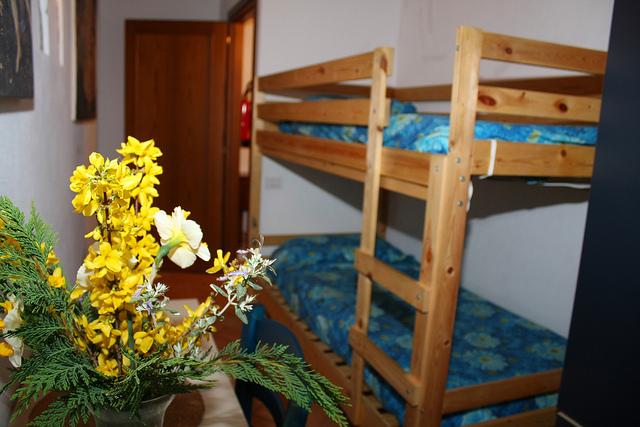What is the print of the bed linens?
Write a very short answer. Floral. Based on the flowers, what season is it?
Answer briefly. Spring. Is this the room of a married couple?
Concise answer only. No. What color are the flowers?
Keep it brief. Yellow. What is under the bed?
Write a very short answer. Another bed. How many people is this bed designed for?
Answer briefly. 2. 